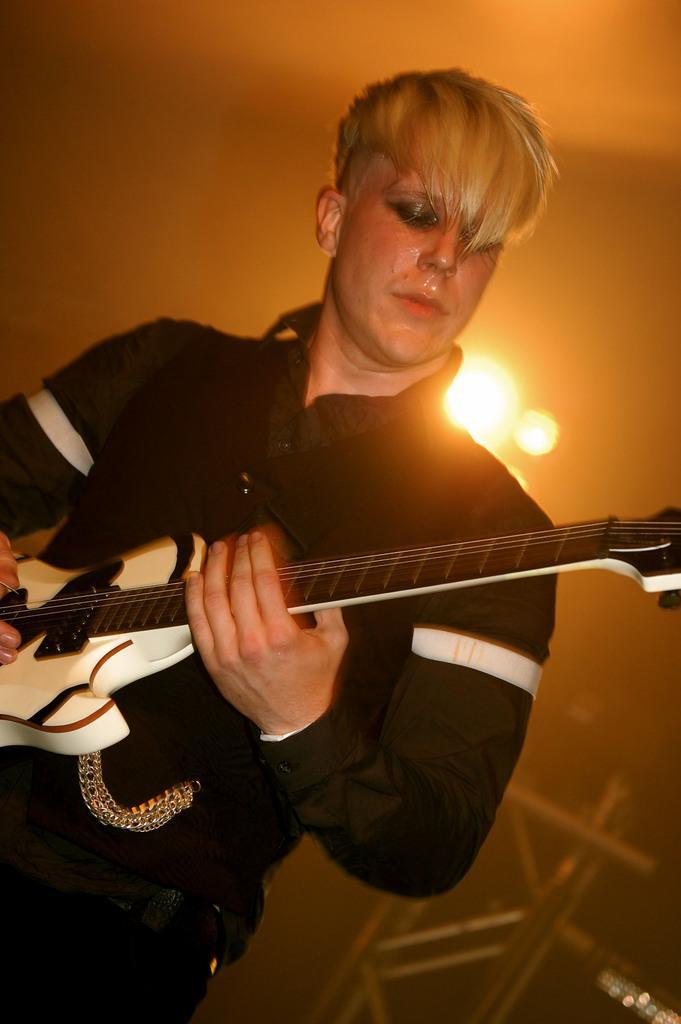Could you give a brief overview of what you see in this image? This person standing and playing guitar,behind this person we can see wall,lights. 